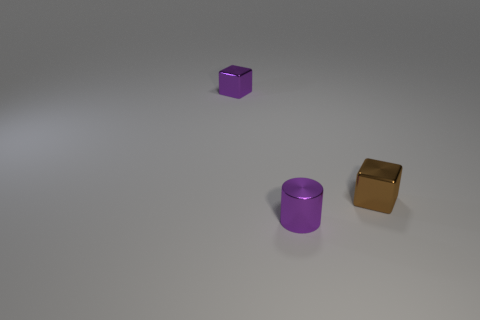There is a tiny cylinder; does it have the same color as the shiny object that is right of the small purple metal cylinder? No, the tiny cylinder does not have the same color as the shiny object to the right of the small purple metal cylinder. The tiny cylinder appears to be a different hue and lacks the metallic sheen of the object beside the purple cylinder. 